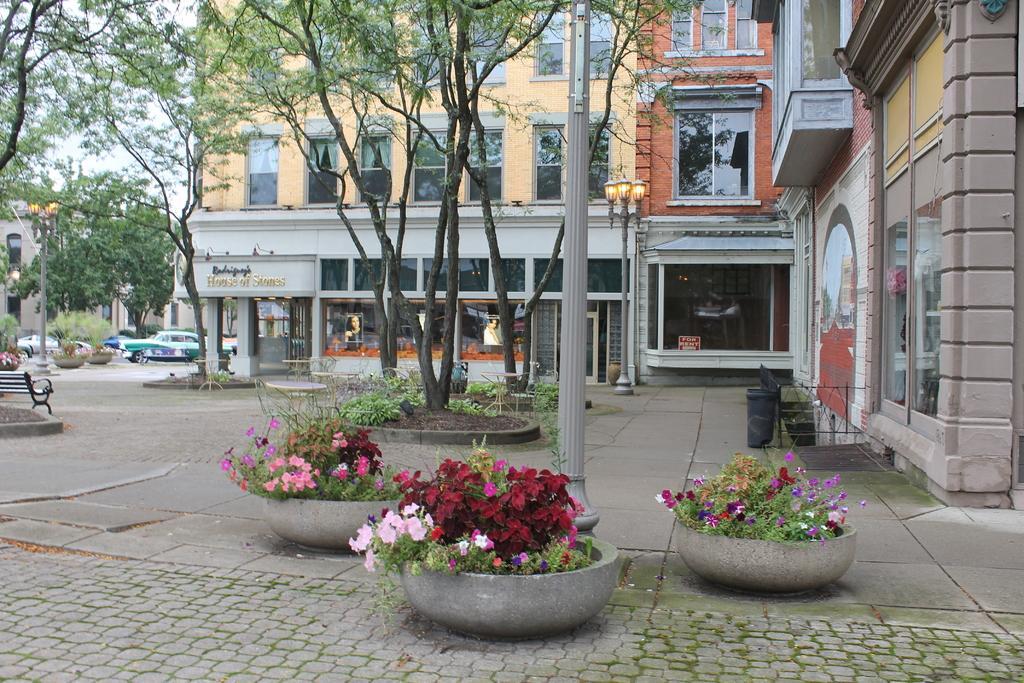In one or two sentences, can you explain what this image depicts? This image is clicked on the road. In the front, there are potted plants. At the bottom, there is a road. On the left, there is a bench along with the cars. On the right, there is a building. On the right, there is a building. In the middle, there are trees. At the top, there is a sky. 